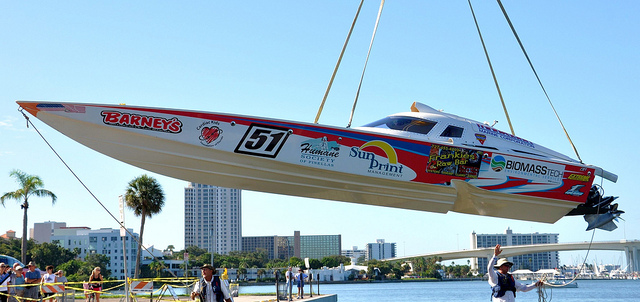Please extract the text content from this image. BARNEY'S 51 BIOMASS Sun Print TED Humane 